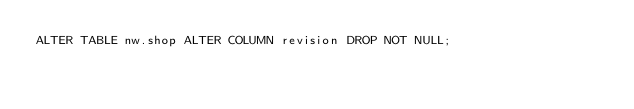<code> <loc_0><loc_0><loc_500><loc_500><_SQL_>ALTER TABLE nw.shop ALTER COLUMN revision DROP NOT NULL;</code> 